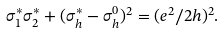<formula> <loc_0><loc_0><loc_500><loc_500>\sigma ^ { * } _ { 1 } \sigma ^ { * } _ { 2 } + ( \sigma ^ { * } _ { h } - \sigma _ { h } ^ { 0 } ) ^ { 2 } = ( e ^ { 2 } / 2 h ) ^ { 2 } .</formula> 